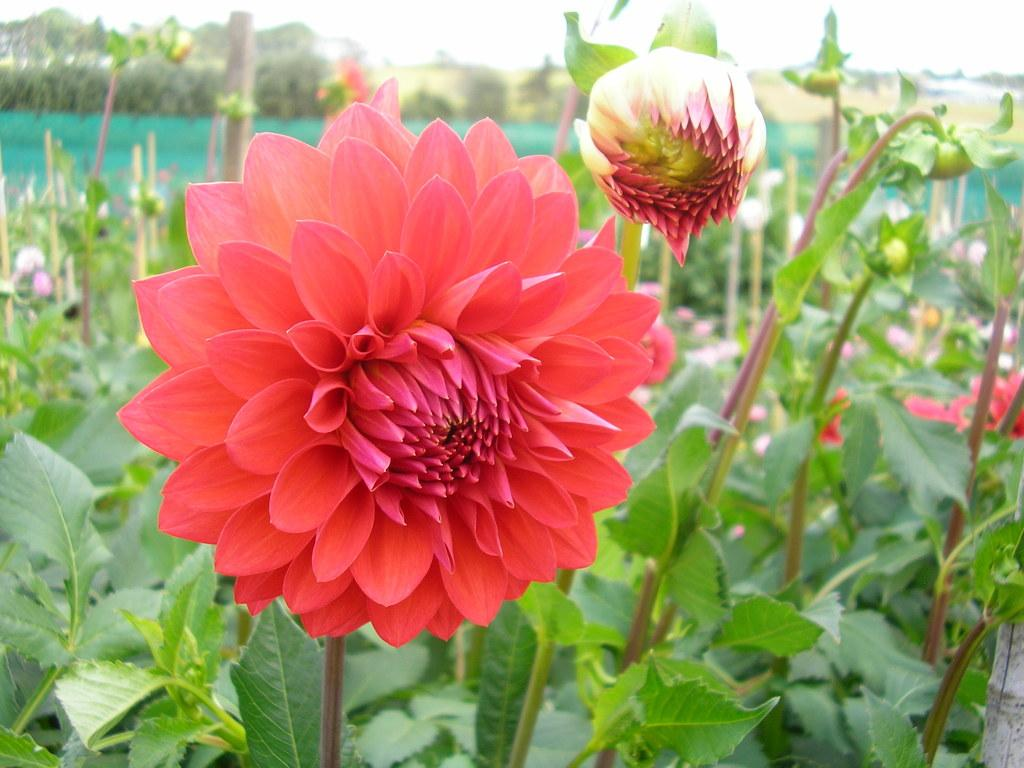What type of plants can be seen in the image? There are many flower plants in the image. Can you describe the flower in the foreground? There is a red flower in the foreground. Are there any flowers that are not fully bloomed in the image? Yes, there is a flower bud on a plant beside the red flower. What type of fiction is the worm reading on the chin in the image? There is no worm or chin present in the image; it features many flower plants with a red flower in the foreground and a flower bud on a nearby plant. 